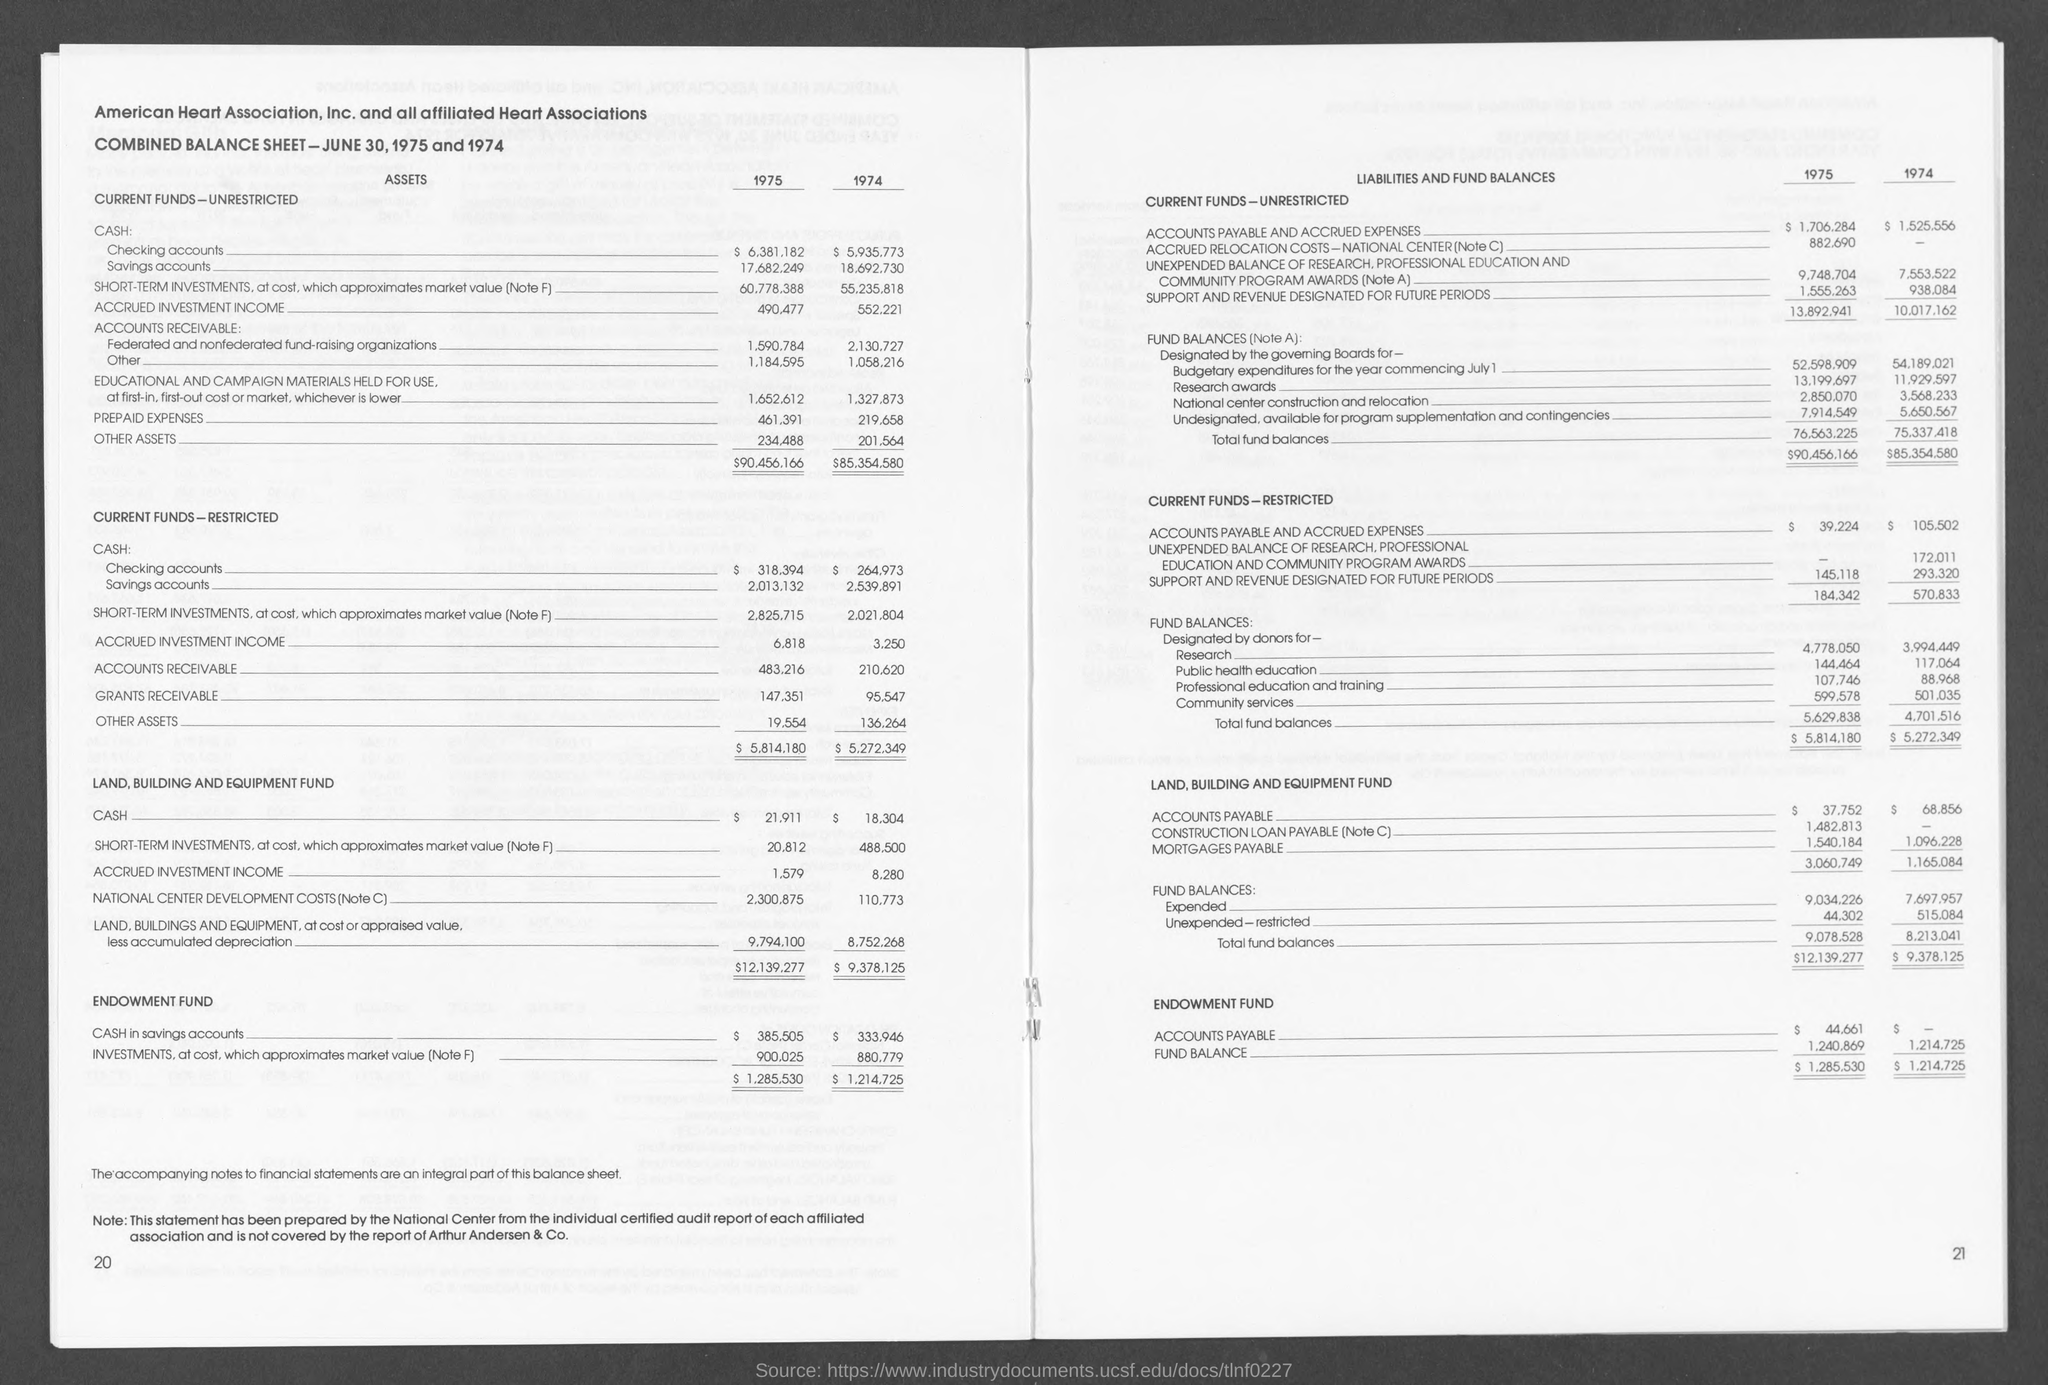Identify some key points in this picture. The number at the bottom-left corner of the page is 20. The number in the bottom-right corner of the page is 21. 